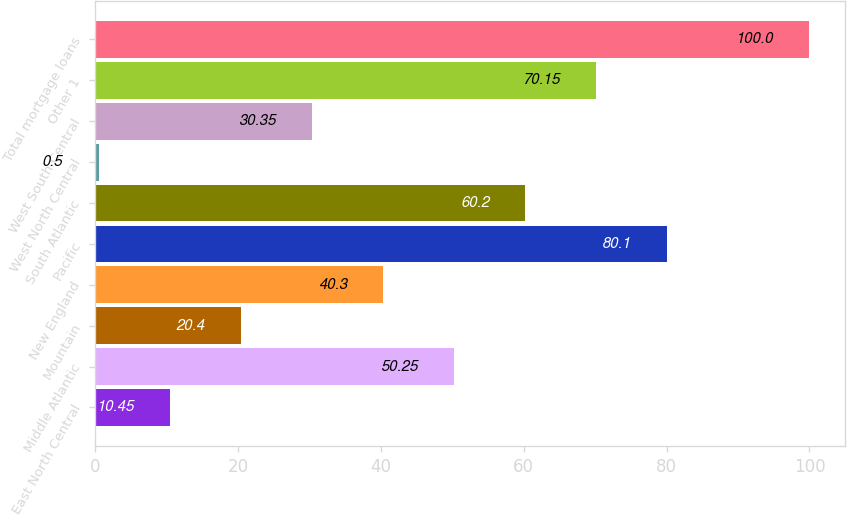<chart> <loc_0><loc_0><loc_500><loc_500><bar_chart><fcel>East North Central<fcel>Middle Atlantic<fcel>Mountain<fcel>New England<fcel>Pacific<fcel>South Atlantic<fcel>West North Central<fcel>West South Central<fcel>Other 1<fcel>Total mortgage loans<nl><fcel>10.45<fcel>50.25<fcel>20.4<fcel>40.3<fcel>80.1<fcel>60.2<fcel>0.5<fcel>30.35<fcel>70.15<fcel>100<nl></chart> 